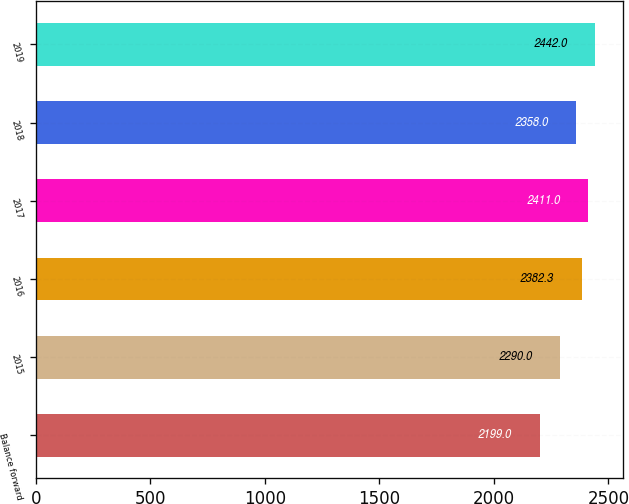<chart> <loc_0><loc_0><loc_500><loc_500><bar_chart><fcel>Balance forward<fcel>2015<fcel>2016<fcel>2017<fcel>2018<fcel>2019<nl><fcel>2199<fcel>2290<fcel>2382.3<fcel>2411<fcel>2358<fcel>2442<nl></chart> 